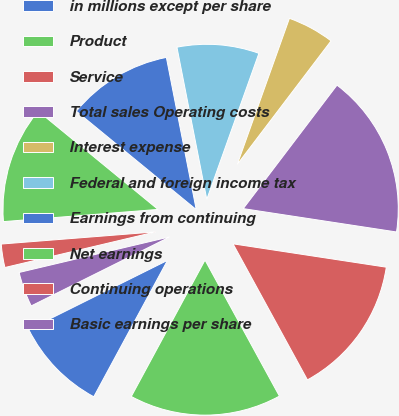Convert chart to OTSL. <chart><loc_0><loc_0><loc_500><loc_500><pie_chart><fcel>in millions except per share<fcel>Product<fcel>Service<fcel>Total sales Operating costs<fcel>Interest expense<fcel>Federal and foreign income tax<fcel>Earnings from continuing<fcel>Net earnings<fcel>Continuing operations<fcel>Basic earnings per share<nl><fcel>9.76%<fcel>15.85%<fcel>14.63%<fcel>17.07%<fcel>4.88%<fcel>8.54%<fcel>10.98%<fcel>12.19%<fcel>2.44%<fcel>3.66%<nl></chart> 